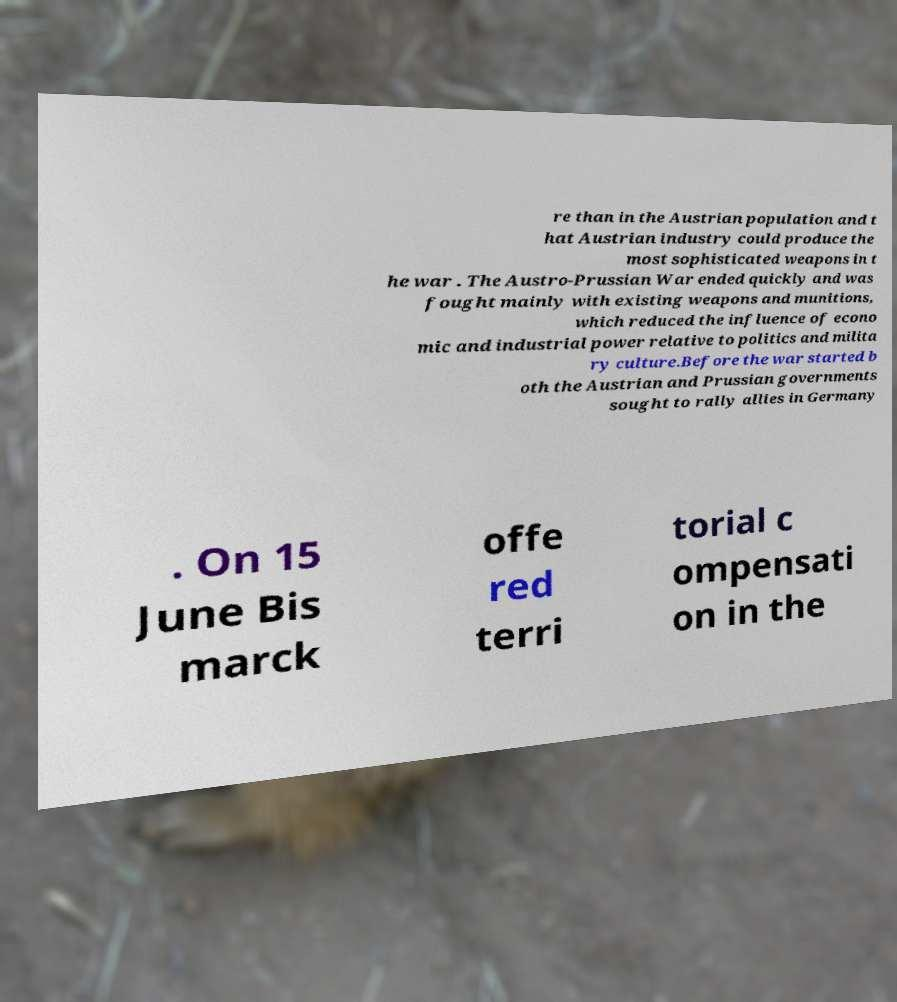For documentation purposes, I need the text within this image transcribed. Could you provide that? re than in the Austrian population and t hat Austrian industry could produce the most sophisticated weapons in t he war . The Austro-Prussian War ended quickly and was fought mainly with existing weapons and munitions, which reduced the influence of econo mic and industrial power relative to politics and milita ry culture.Before the war started b oth the Austrian and Prussian governments sought to rally allies in Germany . On 15 June Bis marck offe red terri torial c ompensati on in the 